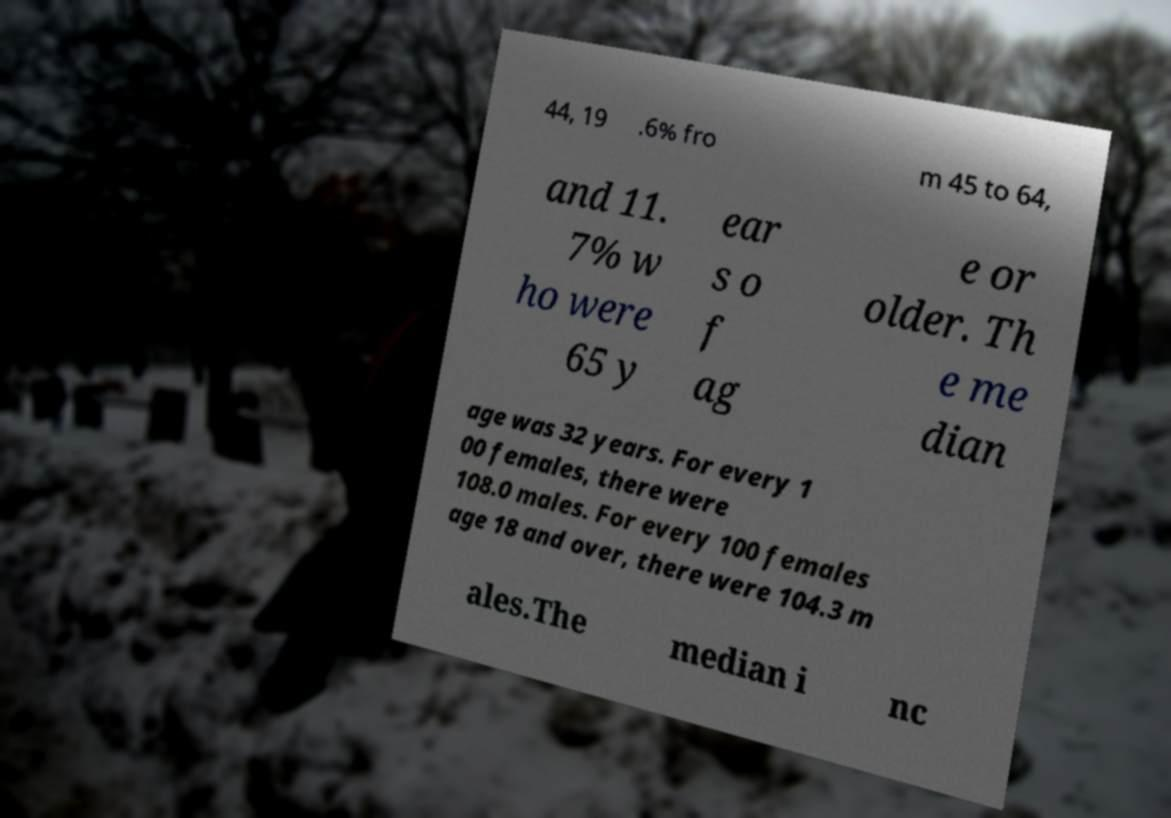Could you extract and type out the text from this image? 44, 19 .6% fro m 45 to 64, and 11. 7% w ho were 65 y ear s o f ag e or older. Th e me dian age was 32 years. For every 1 00 females, there were 108.0 males. For every 100 females age 18 and over, there were 104.3 m ales.The median i nc 